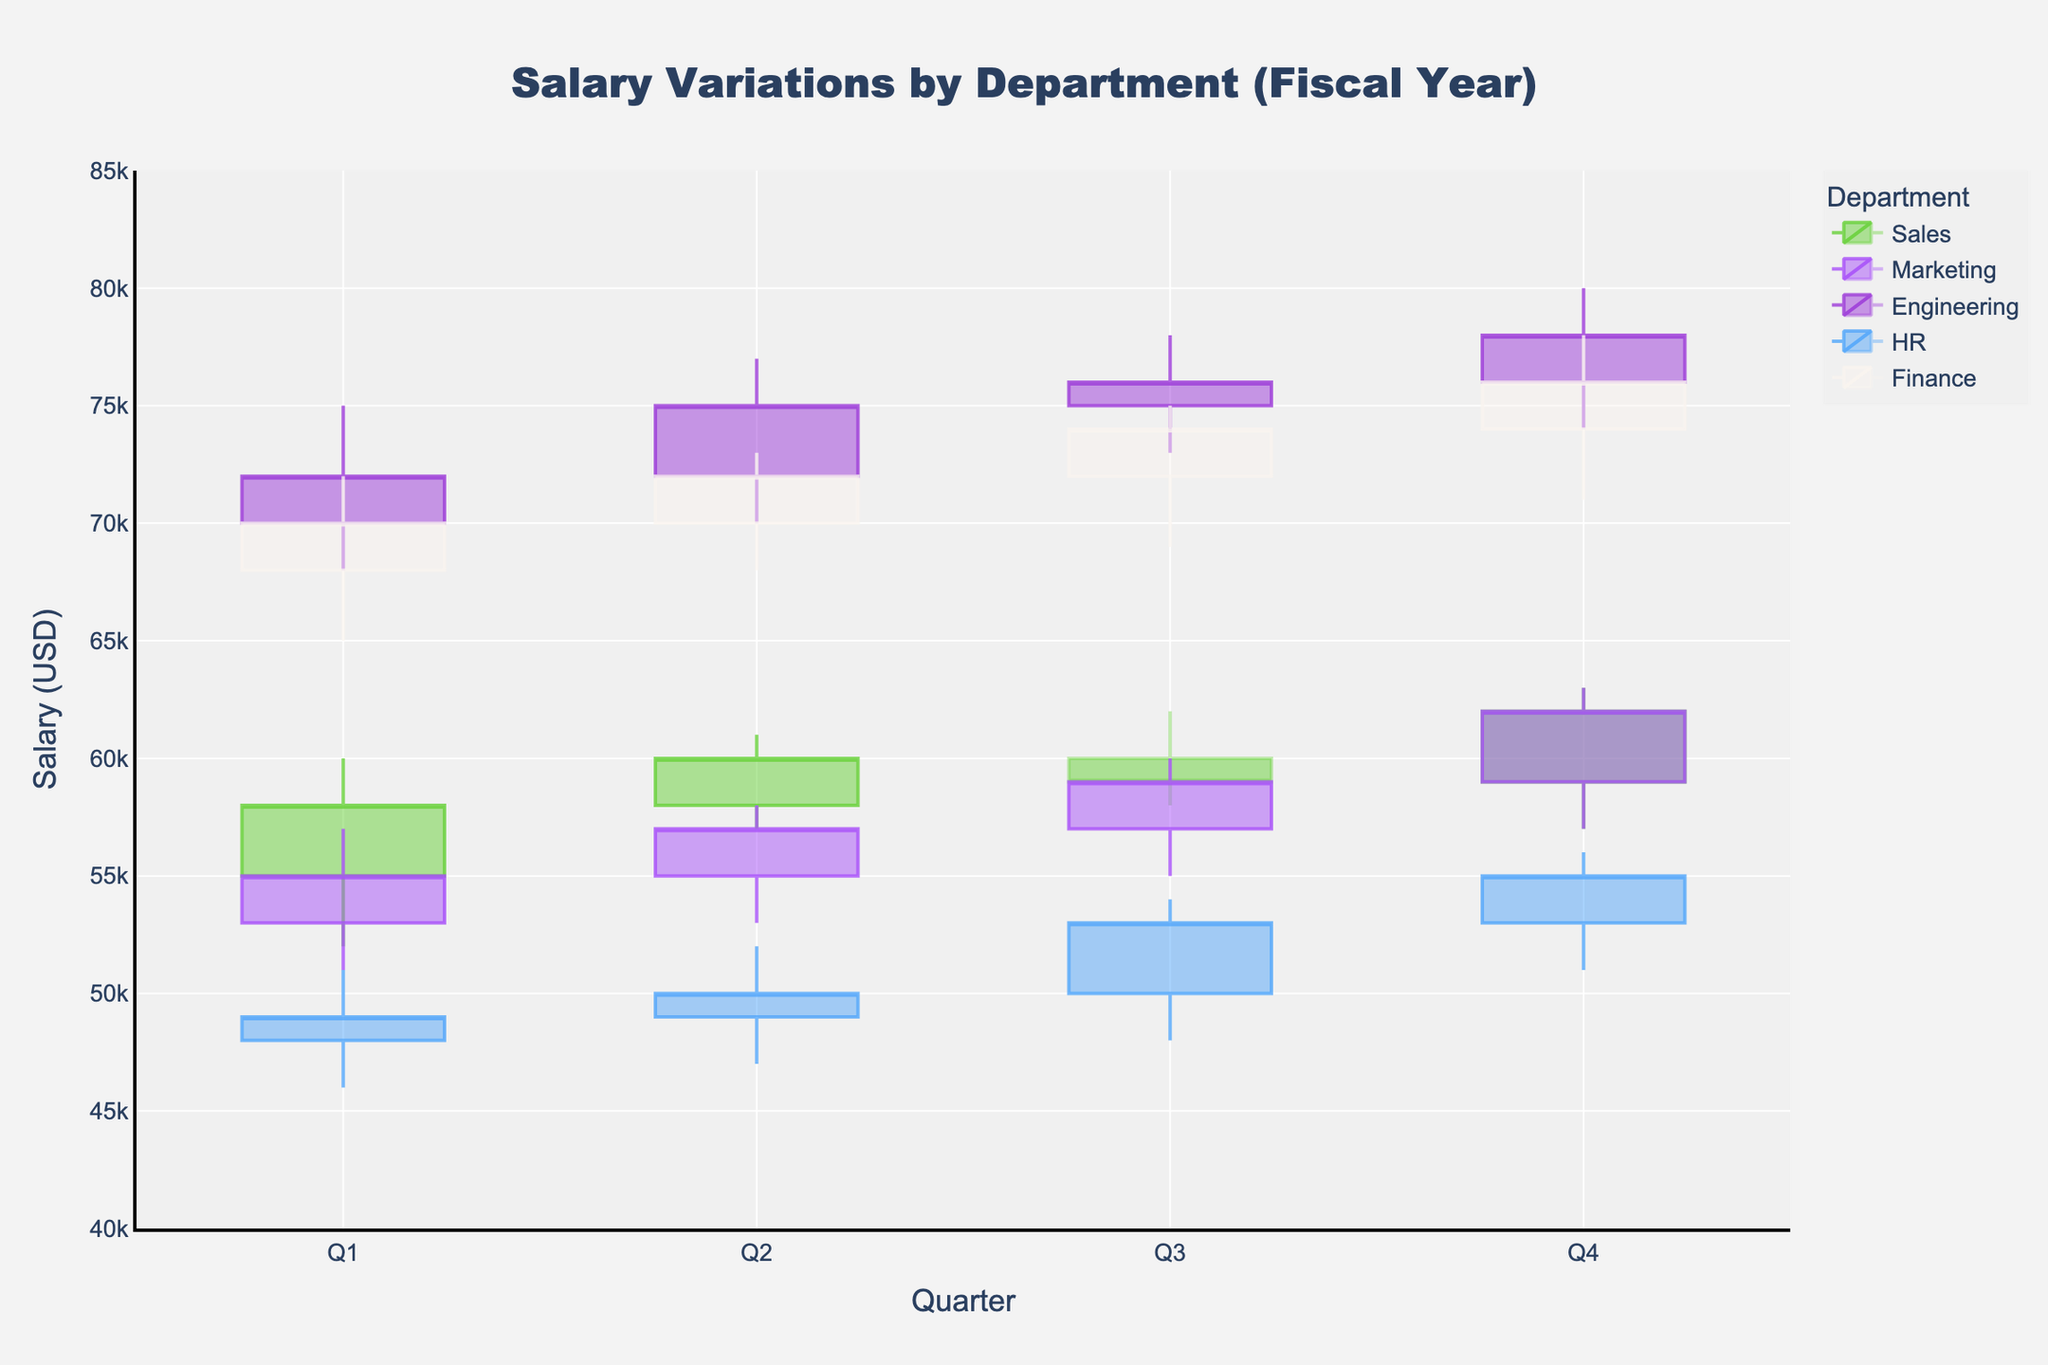What's the title of the figure? The title is usually placed at the top center of the figure. In this case, the title "Salary Variations by Department (Fiscal Year)" is at the top.
Answer: "Salary Variations by Department (Fiscal Year)" What does the x-axis represent? The x-axis generally shows the categories or time periods being analyzed. Here, it represents different quarters from Q1 to Q4.
Answer: Quarters What does the y-axis represent? The y-axis shows the variable being measured. In this figure, it represents the salary in USD.
Answer: Salary (USD) What department had the highest closing salary in Q4? To answer this, we need to look at the closing values of the candlestick plot in Q4. Engineering has a closing salary of $78,000, which is the highest.
Answer: Engineering Which department showed the largest range of salary variation in Q1? To determine the largest range, we look at the difference between the high and low values. The range for each department in Q1 is: Sales (60000-52000=8000), Marketing (57000-51000=6000), Engineering (75000-68000=7000), HR (51000-46000=5000), Finance (72000-65000=7000). Sales has the largest range with 8000.
Answer: Sales Between which two quarters did the Finance department show the greatest increase in the closing salary? We need to compare the closing salaries of Finance between consecutive quarters: Q1($70000) to Q2($72000) is $2000, Q2($72000) to Q3($74000) is $2000, Q3($74000) to Q4($76000) is $2000. All increases are equal.
Answer: Q1 to Q2 / Q2 to Q3 / Q3 to Q4 Which department had a decreasing trend in the closing salary in Q3? To find a decreasing trend, we compare the closing value of Q3 to previous quarters. Only Sales shows a decrease from Q2 to Q3 from $60000 to $59000.
Answer: Sales What was the total closing salary sum for Marketing in all quarters? The closing salaries for Marketing are Q1($55000), Q2($57000), Q3($59000), Q4($62000). Sum them up: $55000 + $57000 + $59000 + $62000 = $233000.
Answer: $233000 How many departments have a closing salary above $70,000 in Q4? In Q4, we look at the closing values: Sales($62000), Marketing($62000), Engineering($78000), HR($55000), Finance($76000). Only Engineering and Finance have closing values above $70,000.
Answer: 2 Which department had the smallest high value in any quarter, and what was it? We look at the high values for all quarters and departments. HR in Q1 had the smallest high value of $51000.
Answer: HR, $51000 